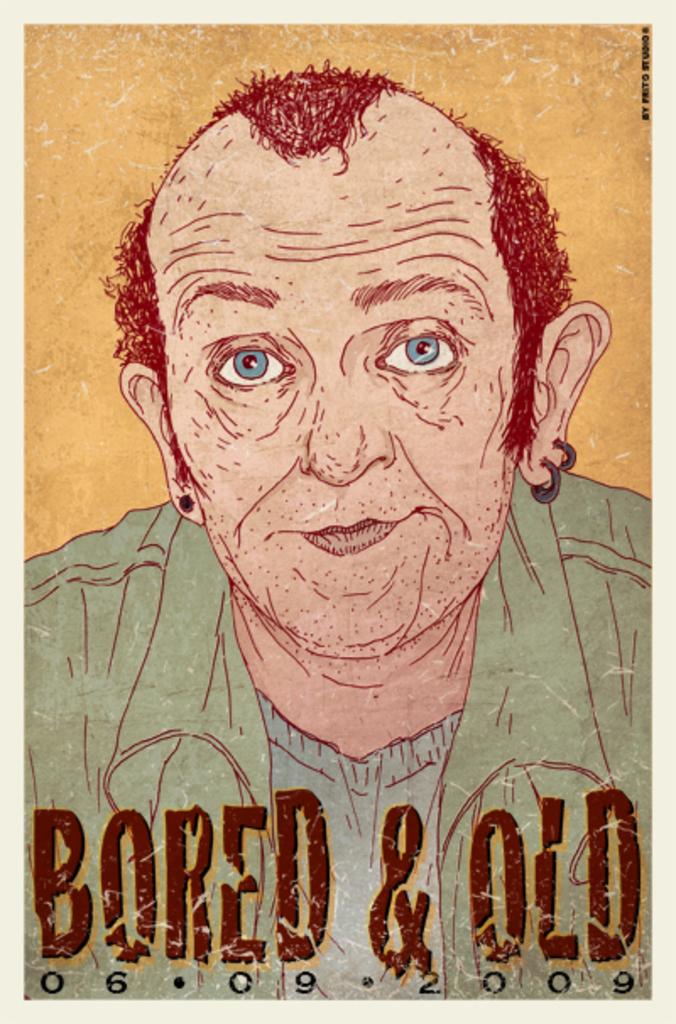When is this event?
Provide a short and direct response. 06-09-2009. What is the event called?
Provide a succinct answer. Bored & old. 